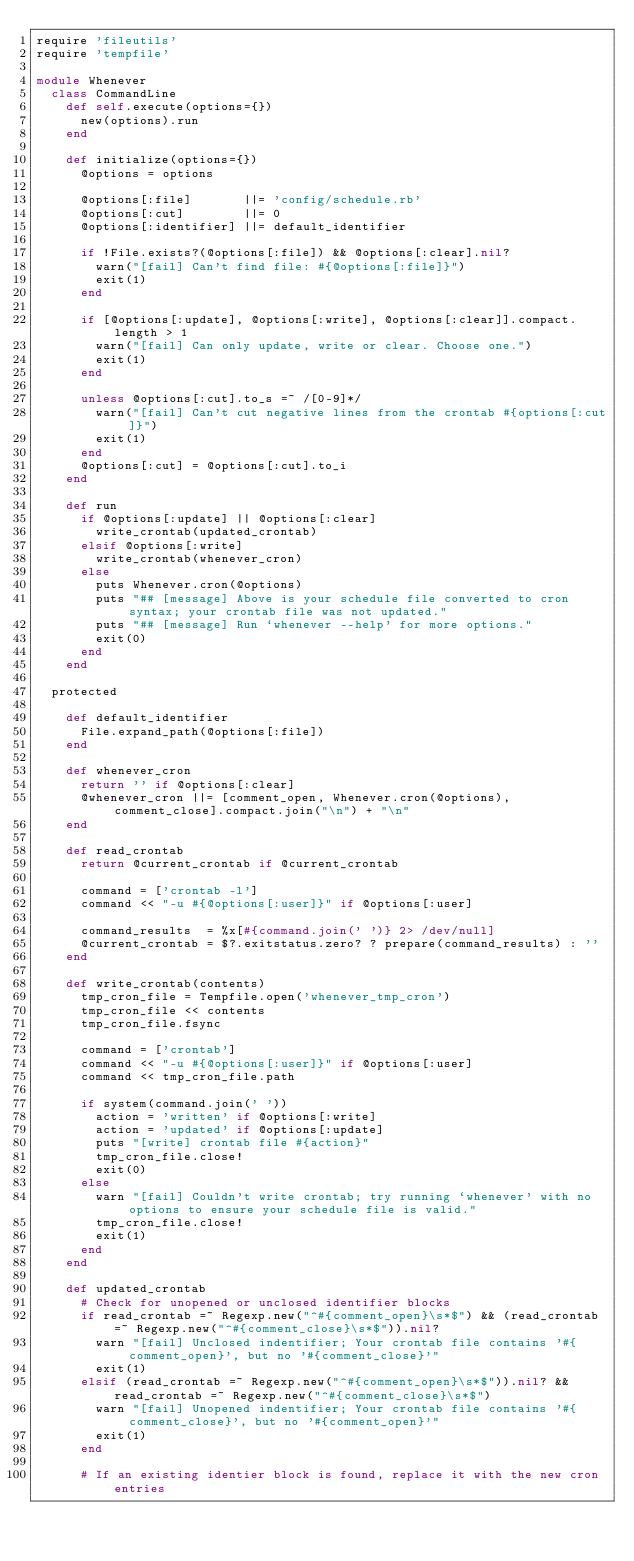Convert code to text. <code><loc_0><loc_0><loc_500><loc_500><_Ruby_>require 'fileutils'
require 'tempfile'

module Whenever
  class CommandLine
    def self.execute(options={})
      new(options).run
    end

    def initialize(options={})
      @options = options

      @options[:file]       ||= 'config/schedule.rb'
      @options[:cut]        ||= 0
      @options[:identifier] ||= default_identifier

      if !File.exists?(@options[:file]) && @options[:clear].nil?
        warn("[fail] Can't find file: #{@options[:file]}")
        exit(1)
      end

      if [@options[:update], @options[:write], @options[:clear]].compact.length > 1
        warn("[fail] Can only update, write or clear. Choose one.")
        exit(1)
      end

      unless @options[:cut].to_s =~ /[0-9]*/
        warn("[fail] Can't cut negative lines from the crontab #{options[:cut]}")
        exit(1)
      end
      @options[:cut] = @options[:cut].to_i
    end

    def run
      if @options[:update] || @options[:clear]
        write_crontab(updated_crontab)
      elsif @options[:write]
        write_crontab(whenever_cron)
      else
        puts Whenever.cron(@options)
        puts "## [message] Above is your schedule file converted to cron syntax; your crontab file was not updated."
        puts "## [message] Run `whenever --help' for more options."
        exit(0)
      end
    end

  protected

    def default_identifier
      File.expand_path(@options[:file])
    end

    def whenever_cron
      return '' if @options[:clear]
      @whenever_cron ||= [comment_open, Whenever.cron(@options), comment_close].compact.join("\n") + "\n"
    end

    def read_crontab
      return @current_crontab if @current_crontab

      command = ['crontab -l']
      command << "-u #{@options[:user]}" if @options[:user]

      command_results  = %x[#{command.join(' ')} 2> /dev/null]
      @current_crontab = $?.exitstatus.zero? ? prepare(command_results) : ''
    end

    def write_crontab(contents)
      tmp_cron_file = Tempfile.open('whenever_tmp_cron')
      tmp_cron_file << contents
      tmp_cron_file.fsync

      command = ['crontab']
      command << "-u #{@options[:user]}" if @options[:user]
      command << tmp_cron_file.path

      if system(command.join(' '))
        action = 'written' if @options[:write]
        action = 'updated' if @options[:update]
        puts "[write] crontab file #{action}"
        tmp_cron_file.close!
        exit(0)
      else
        warn "[fail] Couldn't write crontab; try running `whenever' with no options to ensure your schedule file is valid."
        tmp_cron_file.close!
        exit(1)
      end
    end

    def updated_crontab
      # Check for unopened or unclosed identifier blocks
      if read_crontab =~ Regexp.new("^#{comment_open}\s*$") && (read_crontab =~ Regexp.new("^#{comment_close}\s*$")).nil?
        warn "[fail] Unclosed indentifier; Your crontab file contains '#{comment_open}', but no '#{comment_close}'"
        exit(1)
      elsif (read_crontab =~ Regexp.new("^#{comment_open}\s*$")).nil? && read_crontab =~ Regexp.new("^#{comment_close}\s*$")
        warn "[fail] Unopened indentifier; Your crontab file contains '#{comment_close}', but no '#{comment_open}'"
        exit(1)
      end

      # If an existing identier block is found, replace it with the new cron entries</code> 